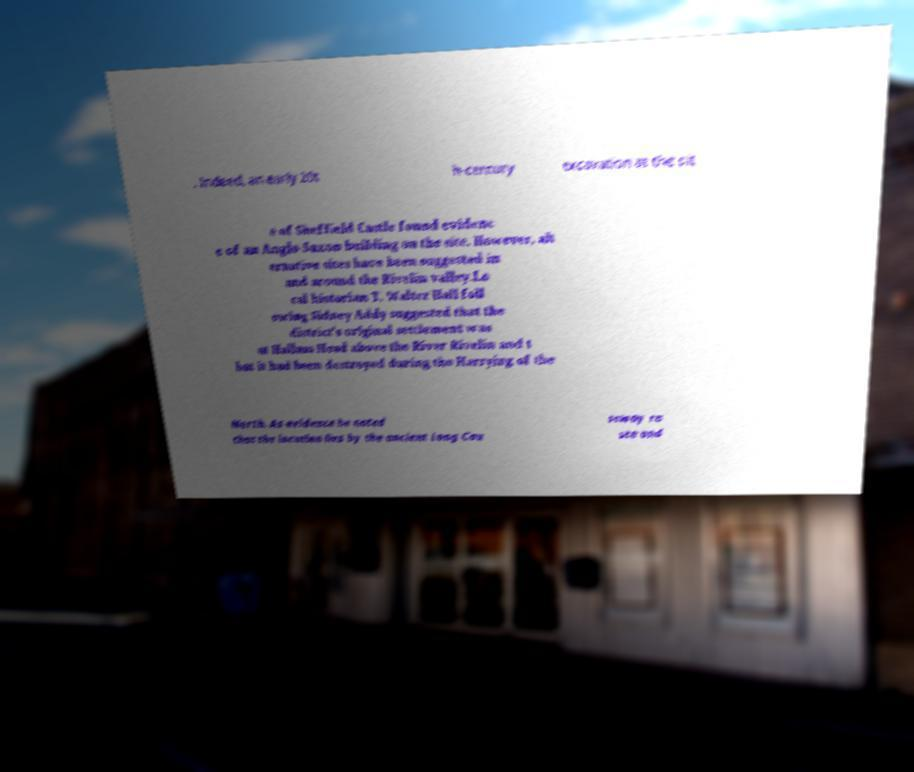For documentation purposes, I need the text within this image transcribed. Could you provide that? . Indeed, an early 20t h-century excavation at the sit e of Sheffield Castle found evidenc e of an Anglo-Saxon building on the site. However, alt ernative sites have been suggested in and around the Rivelin valley.Lo cal historian T. Walter Hall foll owing Sidney Addy suggested that the district's original settlement was at Hallam Head above the River Rivelin and t hat it had been destroyed during the Harrying of the North. As evidence he noted that the location lies by the ancient Long Cau seway ro ute and 